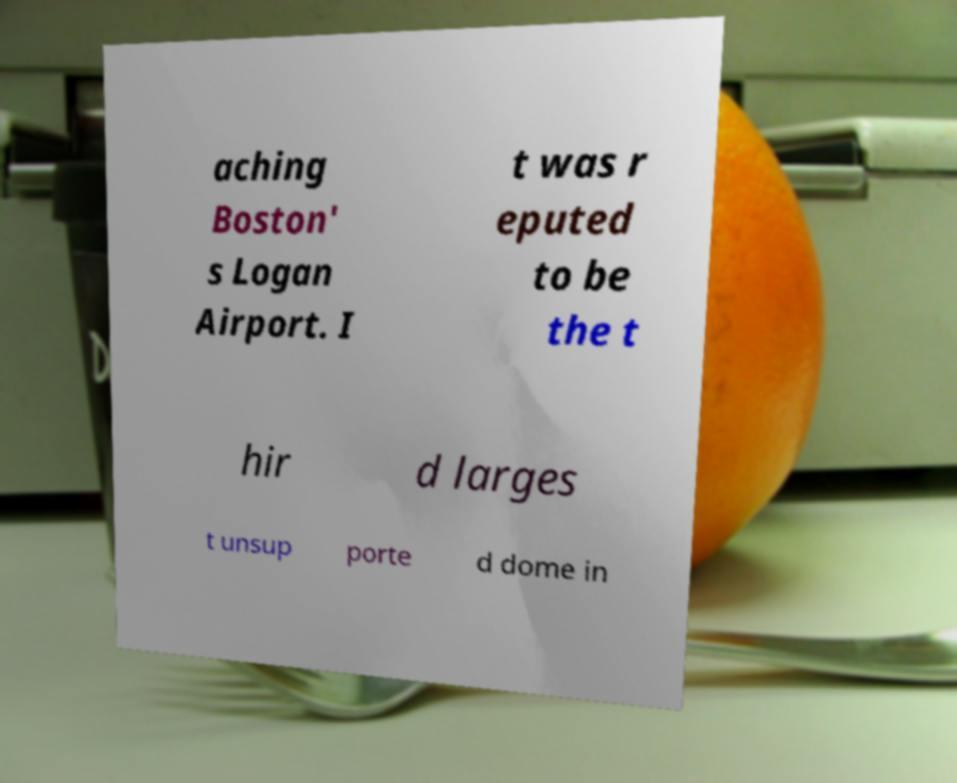For documentation purposes, I need the text within this image transcribed. Could you provide that? aching Boston' s Logan Airport. I t was r eputed to be the t hir d larges t unsup porte d dome in 